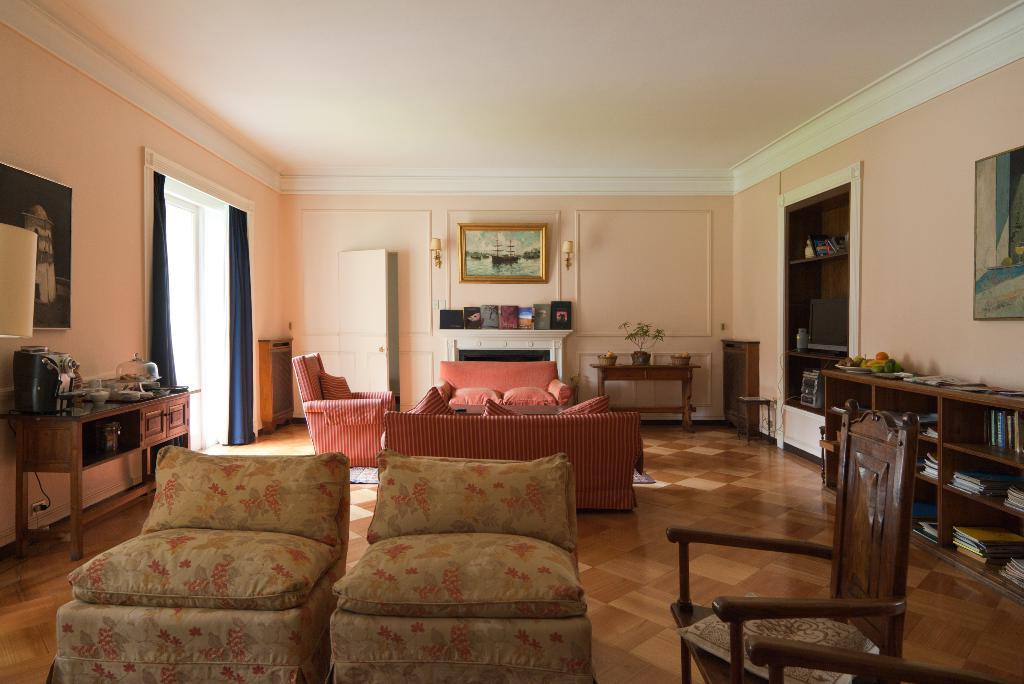What type of room is shown in the image? The image depicts a living room. What type of furniture is present in the living room? There are sofa chairs in the living room. What other types of furniture or storage can be seen in the living room? There are cupboards in the living room. Are there any decorative items or personal touches visible in the living room? Yes, there are photo frames in the living room. What type of insurance policy is being discussed in the living room? There is no indication in the image that an insurance policy is being discussed; the image only shows a living room with sofa chairs, cupboards, and photo frames. 